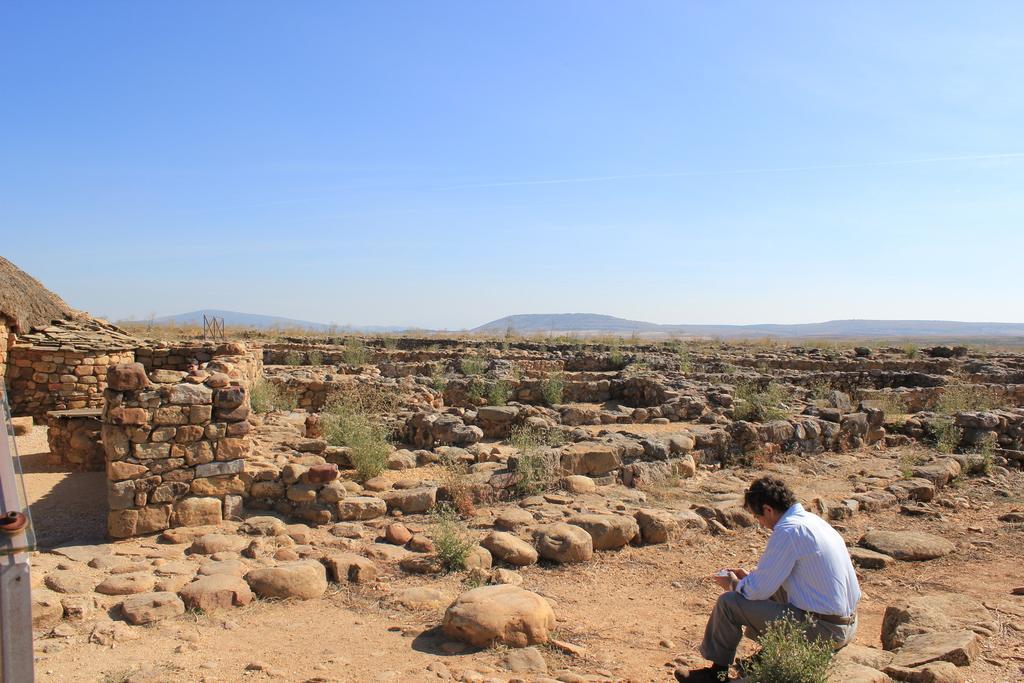Please provide a concise description of this image. In this image we can see a person sitting and there are some rocks and plants and in the background, we can see the mountains and at the top we can see the sky. 